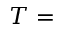Convert formula to latex. <formula><loc_0><loc_0><loc_500><loc_500>T =</formula> 